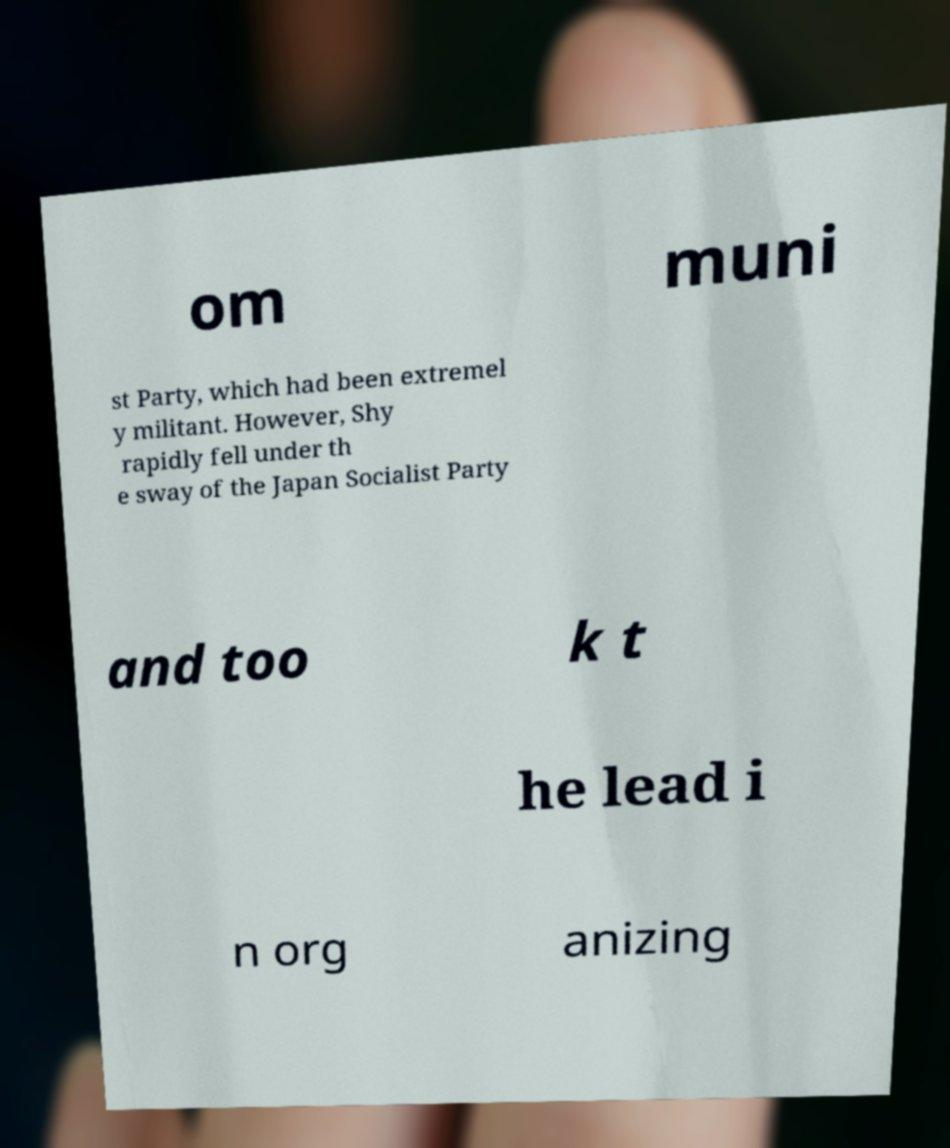Can you read and provide the text displayed in the image?This photo seems to have some interesting text. Can you extract and type it out for me? om muni st Party, which had been extremel y militant. However, Shy rapidly fell under th e sway of the Japan Socialist Party and too k t he lead i n org anizing 